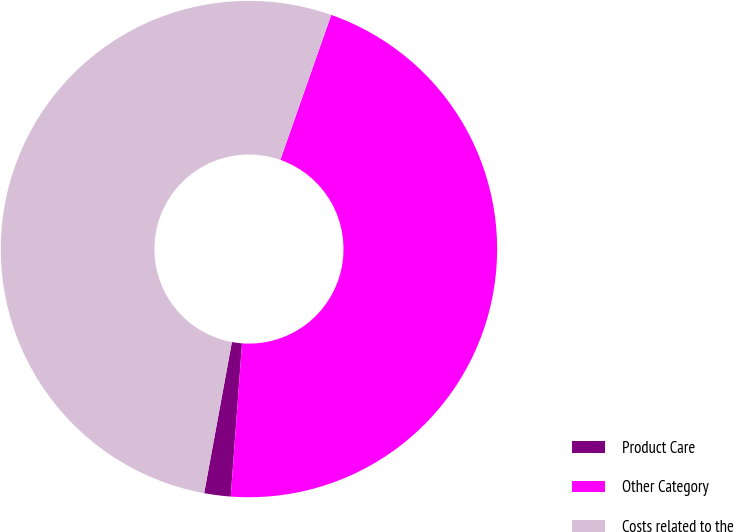<chart> <loc_0><loc_0><loc_500><loc_500><pie_chart><fcel>Product Care<fcel>Other Category<fcel>Costs related to the<nl><fcel>1.72%<fcel>45.79%<fcel>52.49%<nl></chart> 